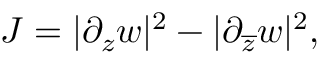Convert formula to latex. <formula><loc_0><loc_0><loc_500><loc_500>J = | \partial _ { z } w | ^ { 2 } - | \partial _ { \overline { z } } w | ^ { 2 } ,</formula> 